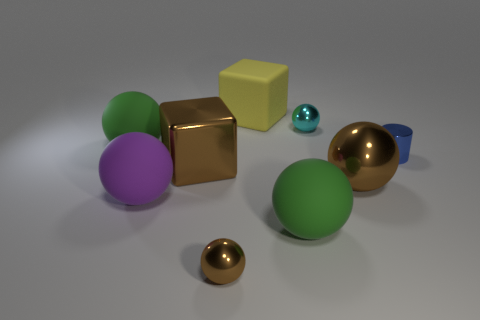What number of purple objects are the same shape as the tiny brown metallic thing?
Give a very brief answer. 1. Is the number of yellow matte blocks less than the number of large blue metallic balls?
Offer a very short reply. No. Is there anything else that has the same color as the large metallic ball?
Make the answer very short. Yes. There is a cyan metallic sphere that is on the right side of the tiny brown ball; how big is it?
Your response must be concise. Small. Are there more brown balls than small green objects?
Your answer should be very brief. Yes. What is the tiny brown ball made of?
Provide a succinct answer. Metal. What number of other objects are there of the same material as the yellow block?
Your answer should be very brief. 3. How many large brown shiny balls are there?
Provide a succinct answer. 1. There is a tiny brown object that is the same shape as the small cyan object; what is it made of?
Make the answer very short. Metal. Is the cube behind the cylinder made of the same material as the tiny cyan object?
Your response must be concise. No. 